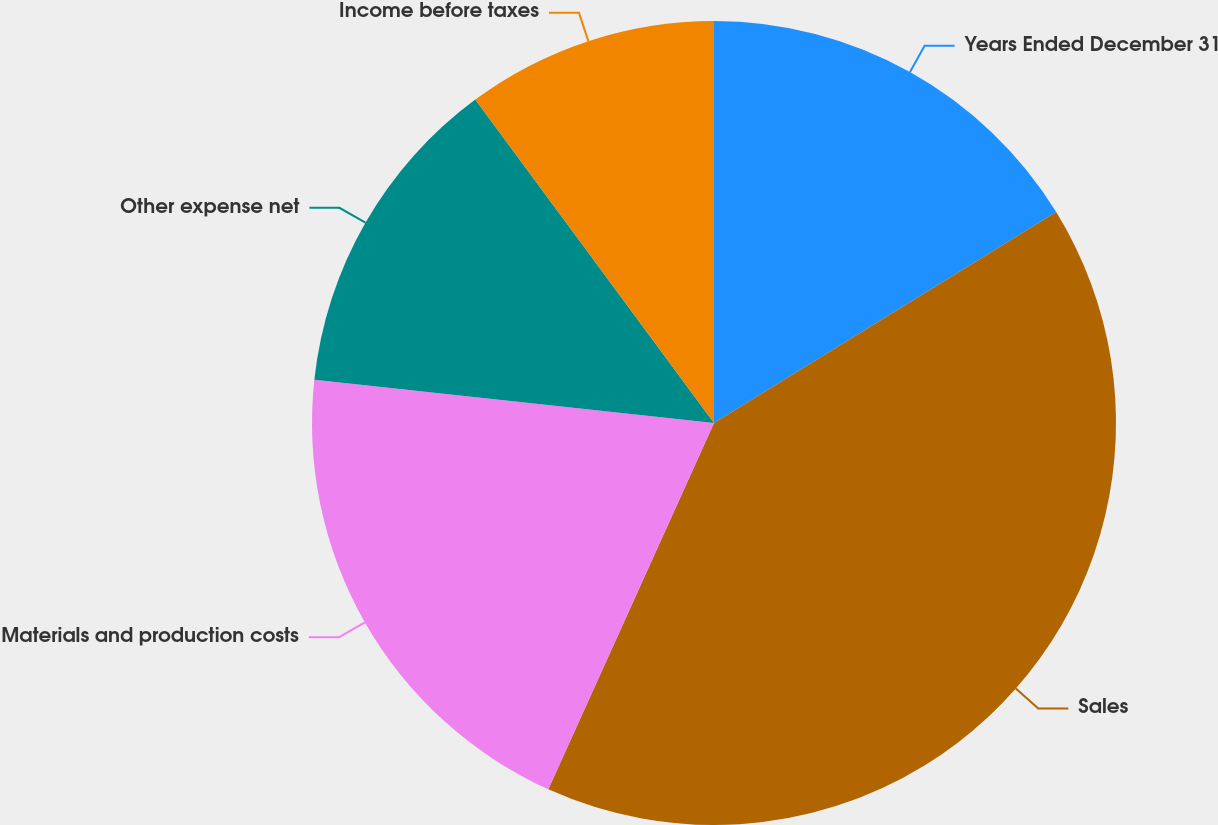<chart> <loc_0><loc_0><loc_500><loc_500><pie_chart><fcel>Years Ended December 31<fcel>Sales<fcel>Materials and production costs<fcel>Other expense net<fcel>Income before taxes<nl><fcel>16.21%<fcel>40.55%<fcel>19.96%<fcel>13.16%<fcel>10.12%<nl></chart> 